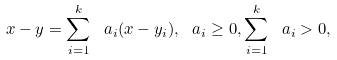Convert formula to latex. <formula><loc_0><loc_0><loc_500><loc_500>x - y = \sum _ { i = 1 } ^ { k } \ a _ { i } ( x - y _ { i } ) , \ a _ { i } \geq 0 , \sum _ { i = 1 } ^ { k } \ a _ { i } > 0 ,</formula> 